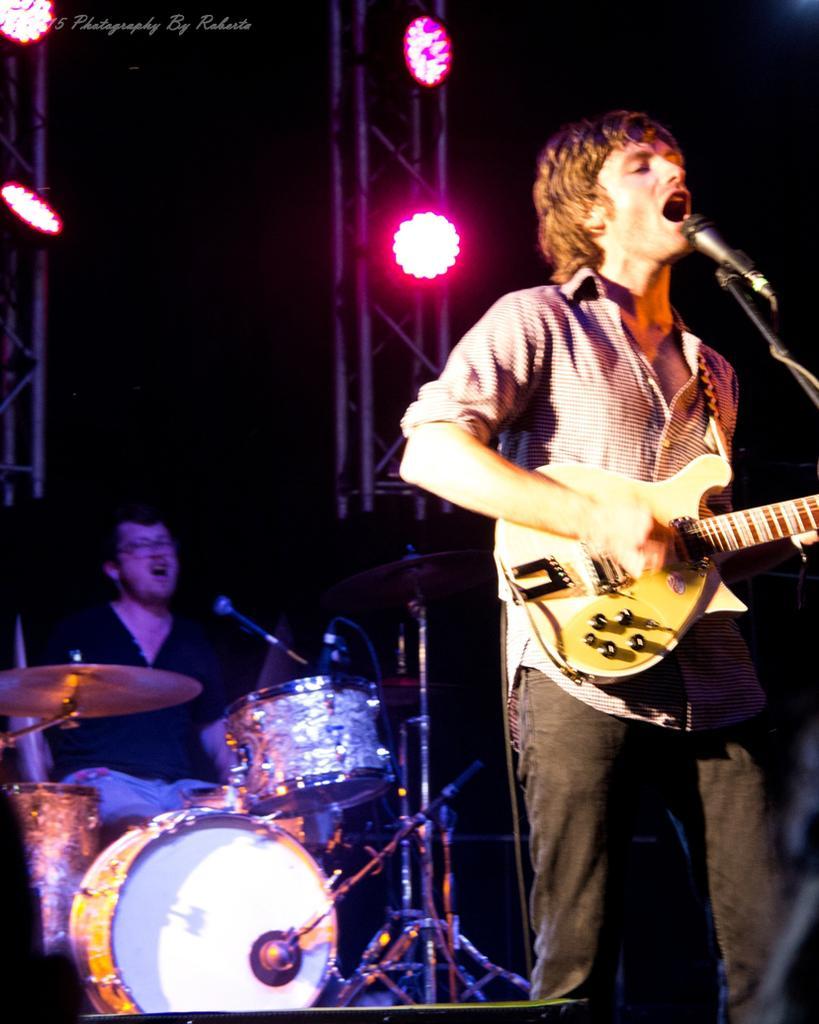Could you give a brief overview of what you see in this image? A person is holding guitar and playing and singing. In front of him there is a mic. In the back there is a person sitting and playing drums. There are lights in the background. 